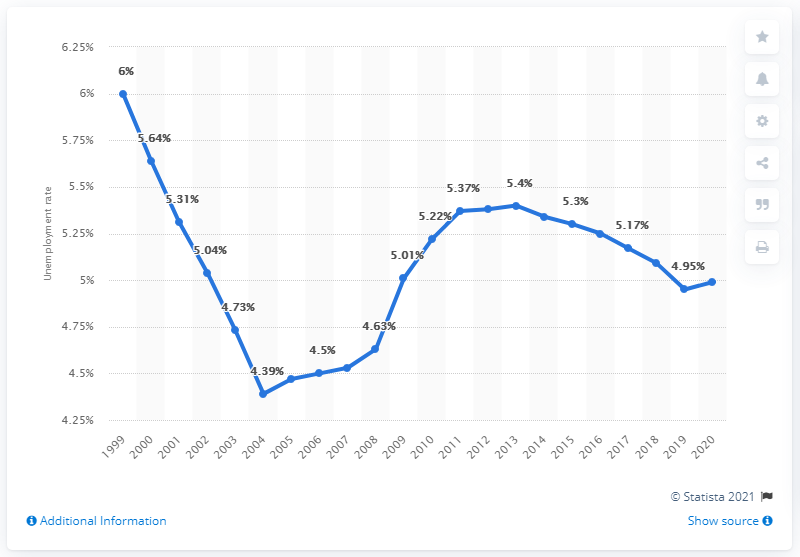Point out several critical features in this image. In 2020, the unemployment rate in Zimbabwe was 4.99%. 